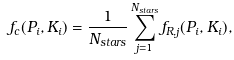<formula> <loc_0><loc_0><loc_500><loc_500>f _ { c } ( P _ { i } , K _ { i } ) = \frac { 1 } { N _ { s t a r s } } \sum _ { j = 1 } ^ { N _ { s t a r s } } f _ { R , j } ( P _ { i } , K _ { i } ) ,</formula> 